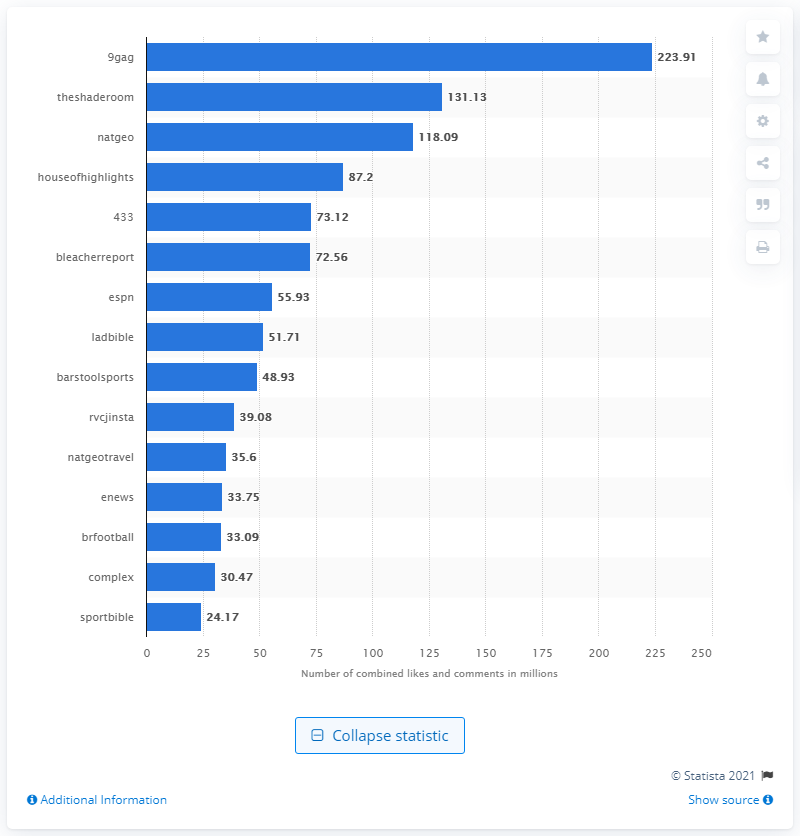List a handful of essential elements in this visual. 9gag had 223.91 user interactions. According to a report released in January 2018, 9gag was the most popular English-language publisher on Instagram. The Shade Room had 131.13 user interactions on Instagram. 